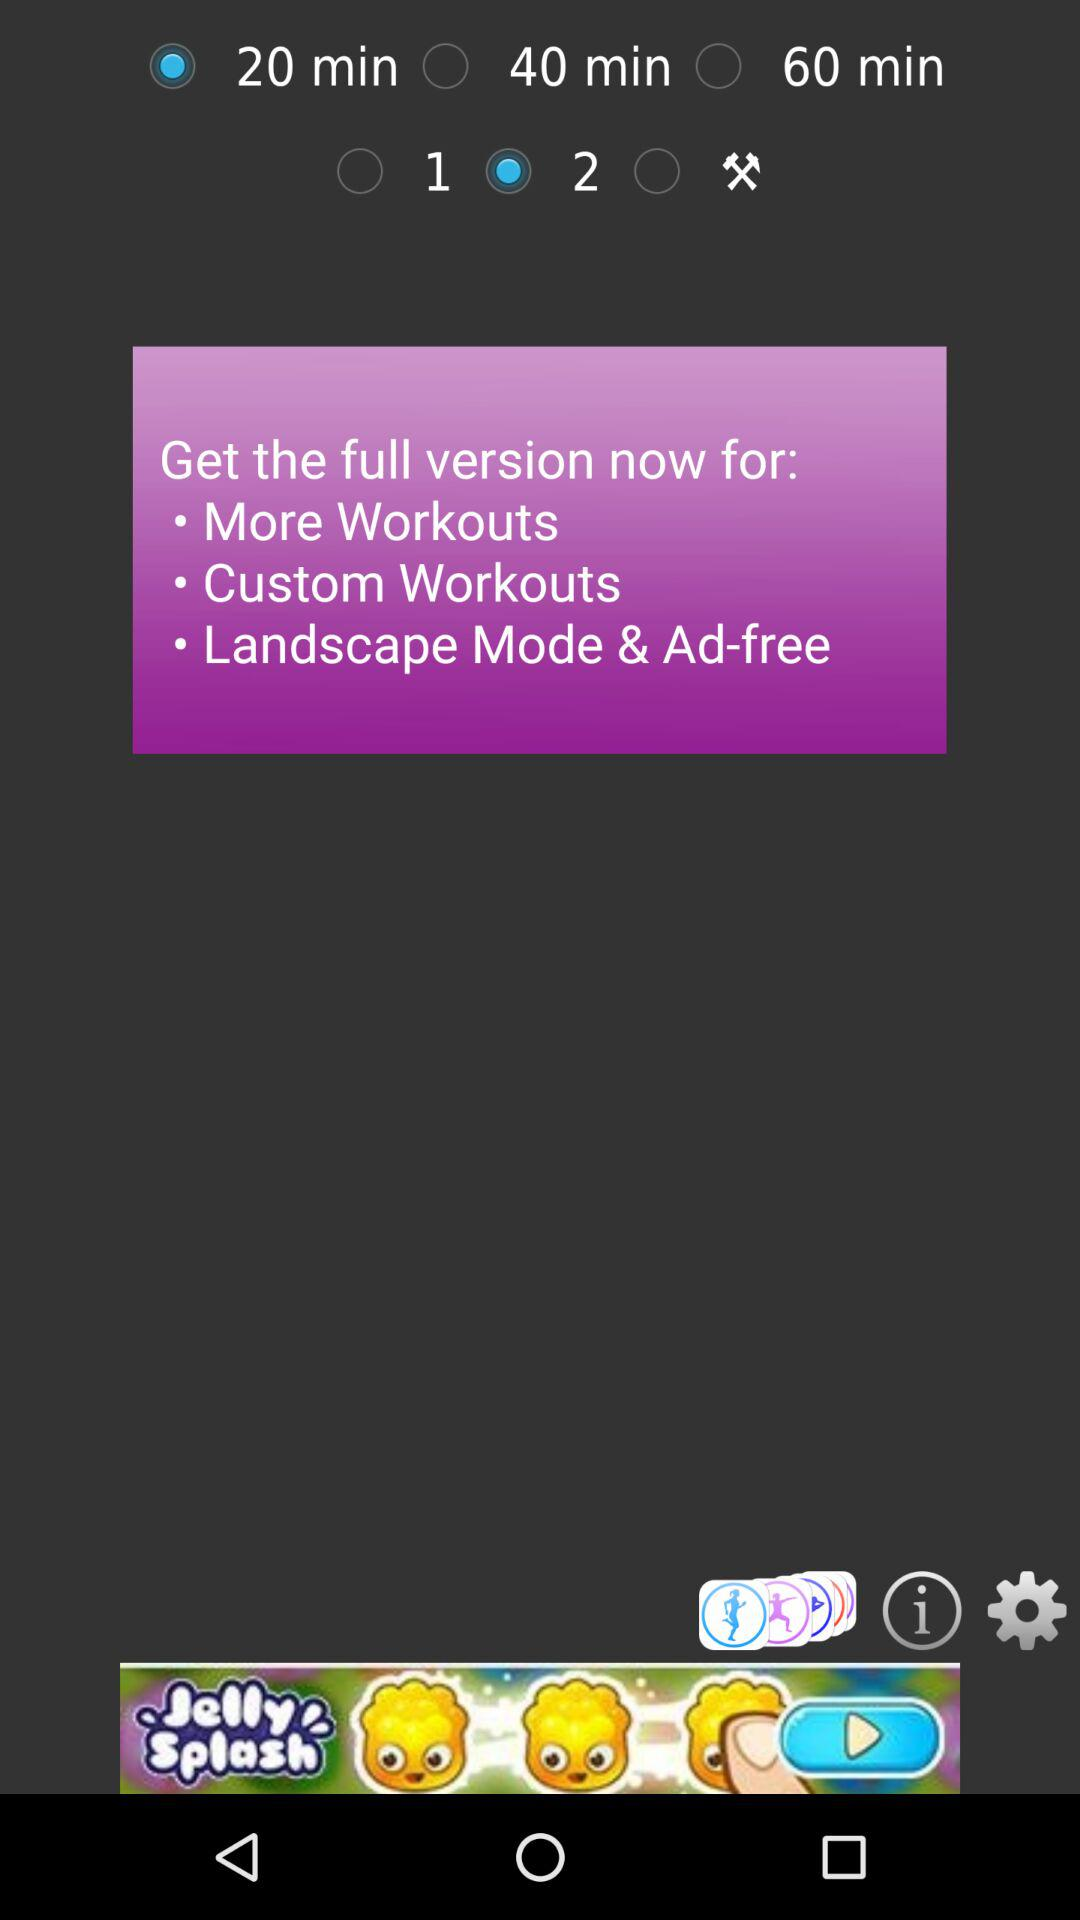How many workout options are there?
Answer the question using a single word or phrase. 3 